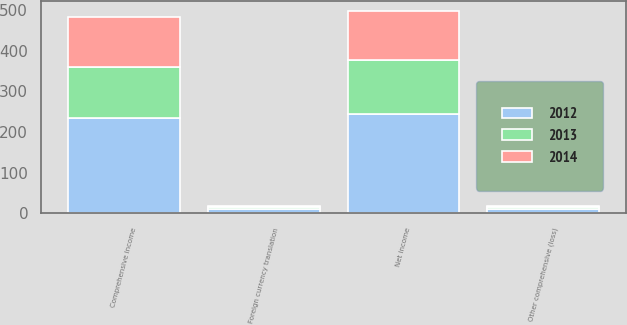<chart> <loc_0><loc_0><loc_500><loc_500><stacked_bar_chart><ecel><fcel>Net income<fcel>Foreign currency translation<fcel>Other comprehensive (loss)<fcel>Comprehensive income<nl><fcel>2012<fcel>244.9<fcel>10.3<fcel>10.3<fcel>234.6<nl><fcel>2013<fcel>132.8<fcel>6.7<fcel>6.7<fcel>126.1<nl><fcel>2014<fcel>119<fcel>2.5<fcel>2.5<fcel>121.5<nl></chart> 